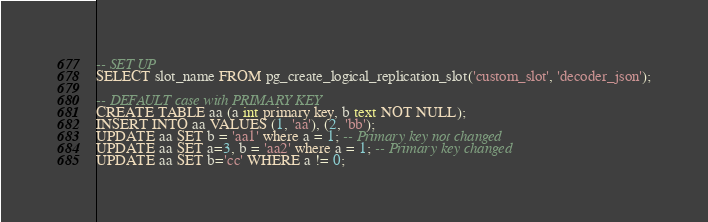Convert code to text. <code><loc_0><loc_0><loc_500><loc_500><_SQL_>-- SET UP
SELECT slot_name FROM pg_create_logical_replication_slot('custom_slot', 'decoder_json');

-- DEFAULT case with PRIMARY KEY
CREATE TABLE aa (a int primary key, b text NOT NULL);
INSERT INTO aa VALUES (1, 'aa'), (2, 'bb');
UPDATE aa SET b = 'aa1' where a = 1; -- Primary key not changed
UPDATE aa SET a=3, b = 'aa2' where a = 1; -- Primary key changed
UPDATE aa SET b='cc' WHERE a != 0;
</code> 